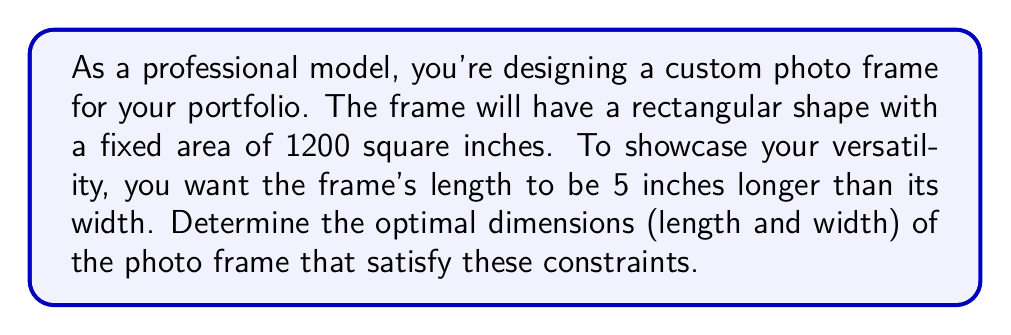Can you answer this question? Let's approach this step-by-step:

1) Let $w$ be the width of the frame and $l$ be the length.

2) Given that the length is 5 inches longer than the width, we can express $l$ in terms of $w$:
   $l = w + 5$

3) We know that the area of a rectangle is given by length times width. Here, the area is fixed at 1200 square inches:
   $A = l \times w = 1200$

4) Substituting the expression for $l$ from step 2:
   $w(w+5) = 1200$

5) Expanding the equation:
   $w^2 + 5w = 1200$

6) Rearranging to standard quadratic form:
   $w^2 + 5w - 1200 = 0$

7) We can solve this using the quadratic formula: $w = \frac{-b \pm \sqrt{b^2 - 4ac}}{2a}$
   Where $a=1$, $b=5$, and $c=-1200$

8) Substituting these values:
   $$w = \frac{-5 \pm \sqrt{5^2 - 4(1)(-1200)}}{2(1)} = \frac{-5 \pm \sqrt{25 + 4800}}{2} = \frac{-5 \pm \sqrt{4825}}{2}$$

9) Simplifying:
   $$w = \frac{-5 \pm 69.46}{2}$$

10) This gives us two solutions:
    $w_1 = \frac{-5 + 69.46}{2} = 32.23$ and $w_2 = \frac{-5 - 69.46}{2} = -37.23$

11) Since width cannot be negative, we take $w = 32.23$ inches.

12) To find the length, we use $l = w + 5 = 32.23 + 5 = 37.23$ inches.

Therefore, the optimal dimensions are approximately 32.23 inches for width and 37.23 inches for length.
Answer: Width ≈ 32.23 inches, Length ≈ 37.23 inches 